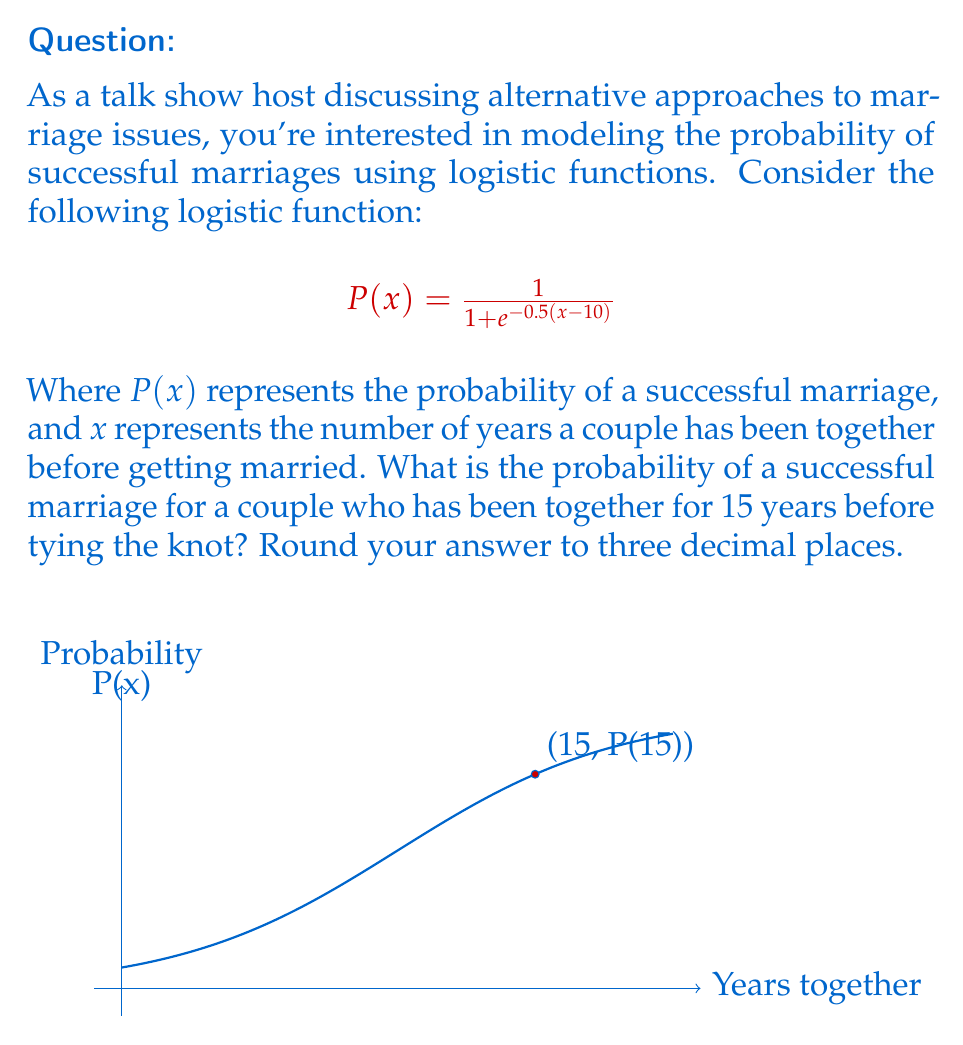Could you help me with this problem? Let's approach this step-by-step:

1) We're given the logistic function:
   $$P(x) = \frac{1}{1 + e^{-0.5(x-10)}}$$

2) We need to find P(15), as the couple has been together for 15 years.

3) Let's substitute x = 15 into the function:
   $$P(15) = \frac{1}{1 + e^{-0.5(15-10)}}$$

4) Simplify the exponent:
   $$P(15) = \frac{1}{1 + e^{-0.5(5)}} = \frac{1}{1 + e^{-2.5}}$$

5) Calculate $e^{-2.5}$:
   $e^{-2.5} \approx 0.0820$

6) Now our equation looks like:
   $$P(15) = \frac{1}{1 + 0.0820}$$

7) Calculate the denominator:
   $$P(15) = \frac{1}{1.0820}$$

8) Divide:
   $$P(15) \approx 0.9242$$

9) Rounding to three decimal places:
   $$P(15) \approx 0.924$$

Therefore, the probability of a successful marriage for a couple who has been together for 15 years before getting married is approximately 0.924 or 92.4%.
Answer: 0.924 